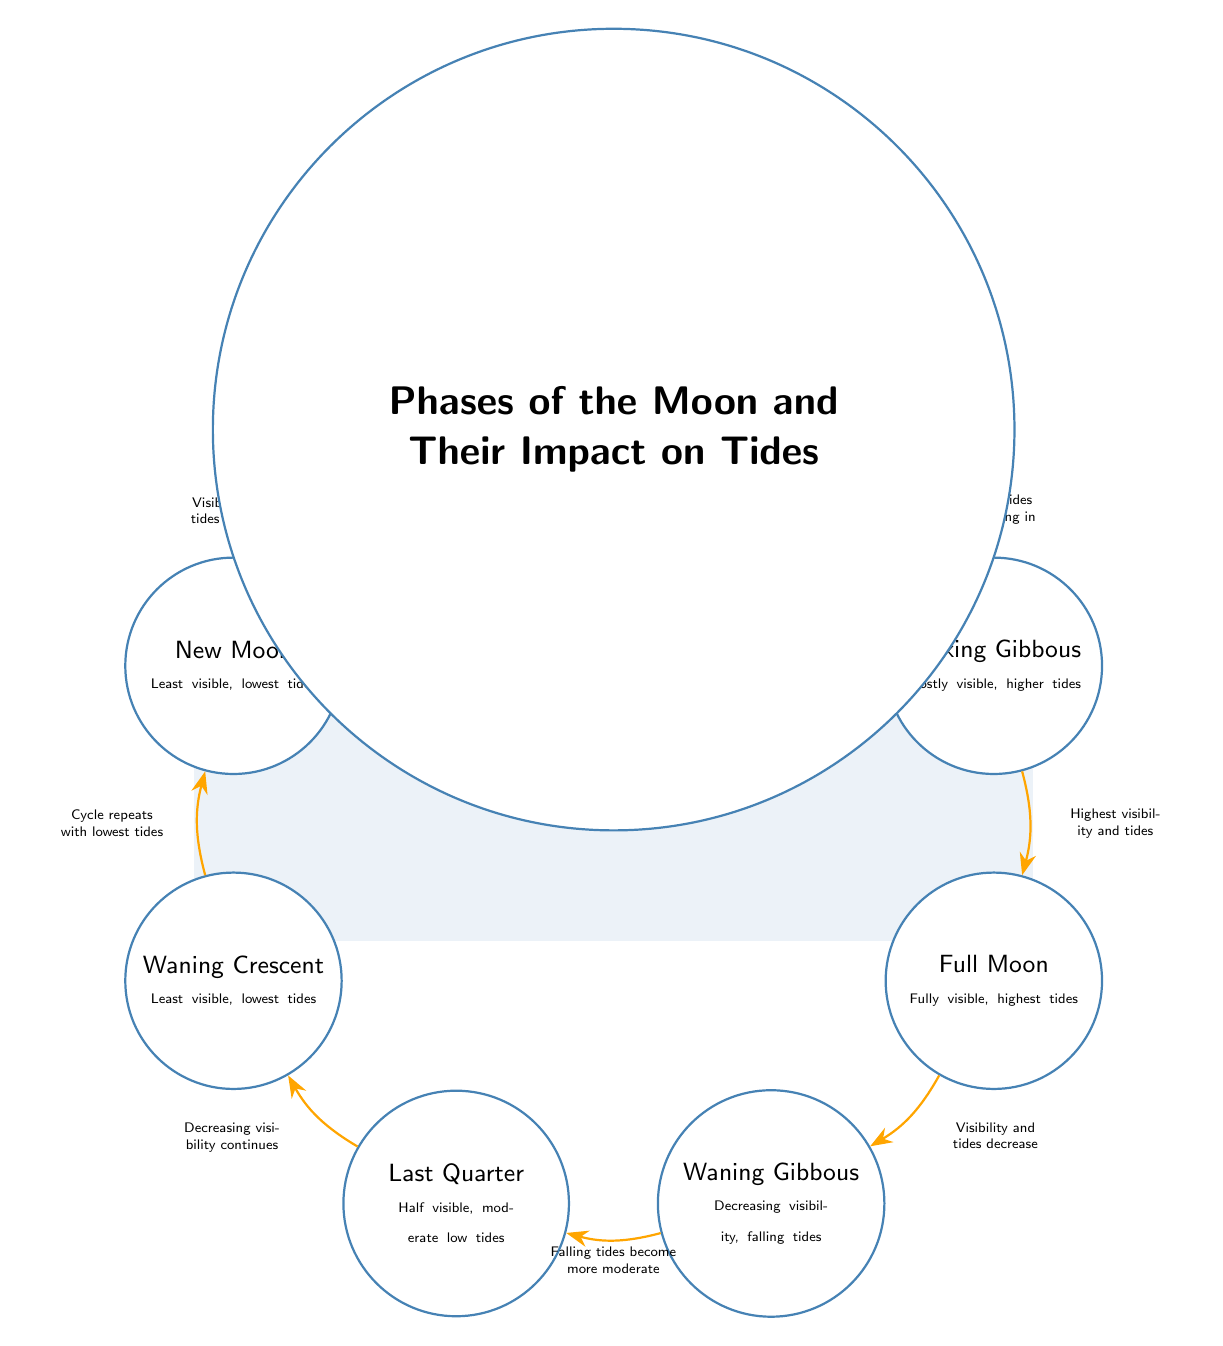What is the visibility status at the New Moon phase? The New Moon phase is described with "Least visible," which is explicitly mentioned in the node corresponding to this phase.
Answer: Least visible How many phases of the moon are depicted in the diagram? By counting the nodes in the diagram, there are a total of eight phases shown, from New Moon to Waning Crescent.
Answer: 8 What label describes the relationship between Waning Gibbous and Last Quarter? The edge between these two nodes has the label "Falling tides become more moderate," which specifies the relationship regarding visibility and tides.
Answer: Falling tides become more moderate Which phase has the highest visibility and highest tides? According to the diagram, the Full Moon is noted as being "Fully visible" and accompanied by "highest tides."
Answer: Full Moon What is the impact of the Full Moon on visibility and tides? The edge leading from the Full Moon to Waning Gibbous is labeled "Visibility and tides decrease," indicating that both visibility and tides are decreasing.
Answer: Decrease What happens to visibility and tides from Last Quarter to Waning Crescent? The relationship is specified by the edge which states "Decreasing visibility continues," indicating a continuous decline in visibility as one moves toward the Waning Crescent.
Answer: Continues decreasing Which phase follows the First Quarter in terms of increasing visibility? The diagram shows that the First Quarter is followed by the Waxing Gibbous phase, which is where visibility continues to increase further.
Answer: Waxing Gibbous What is the effect of transitioning from Waxing Crescent to First Quarter? The edge label indicates that "Visibility increases further" when moving from Waxing Crescent to First Quarter, representing an increase in both visibility and tides.
Answer: Increases further 